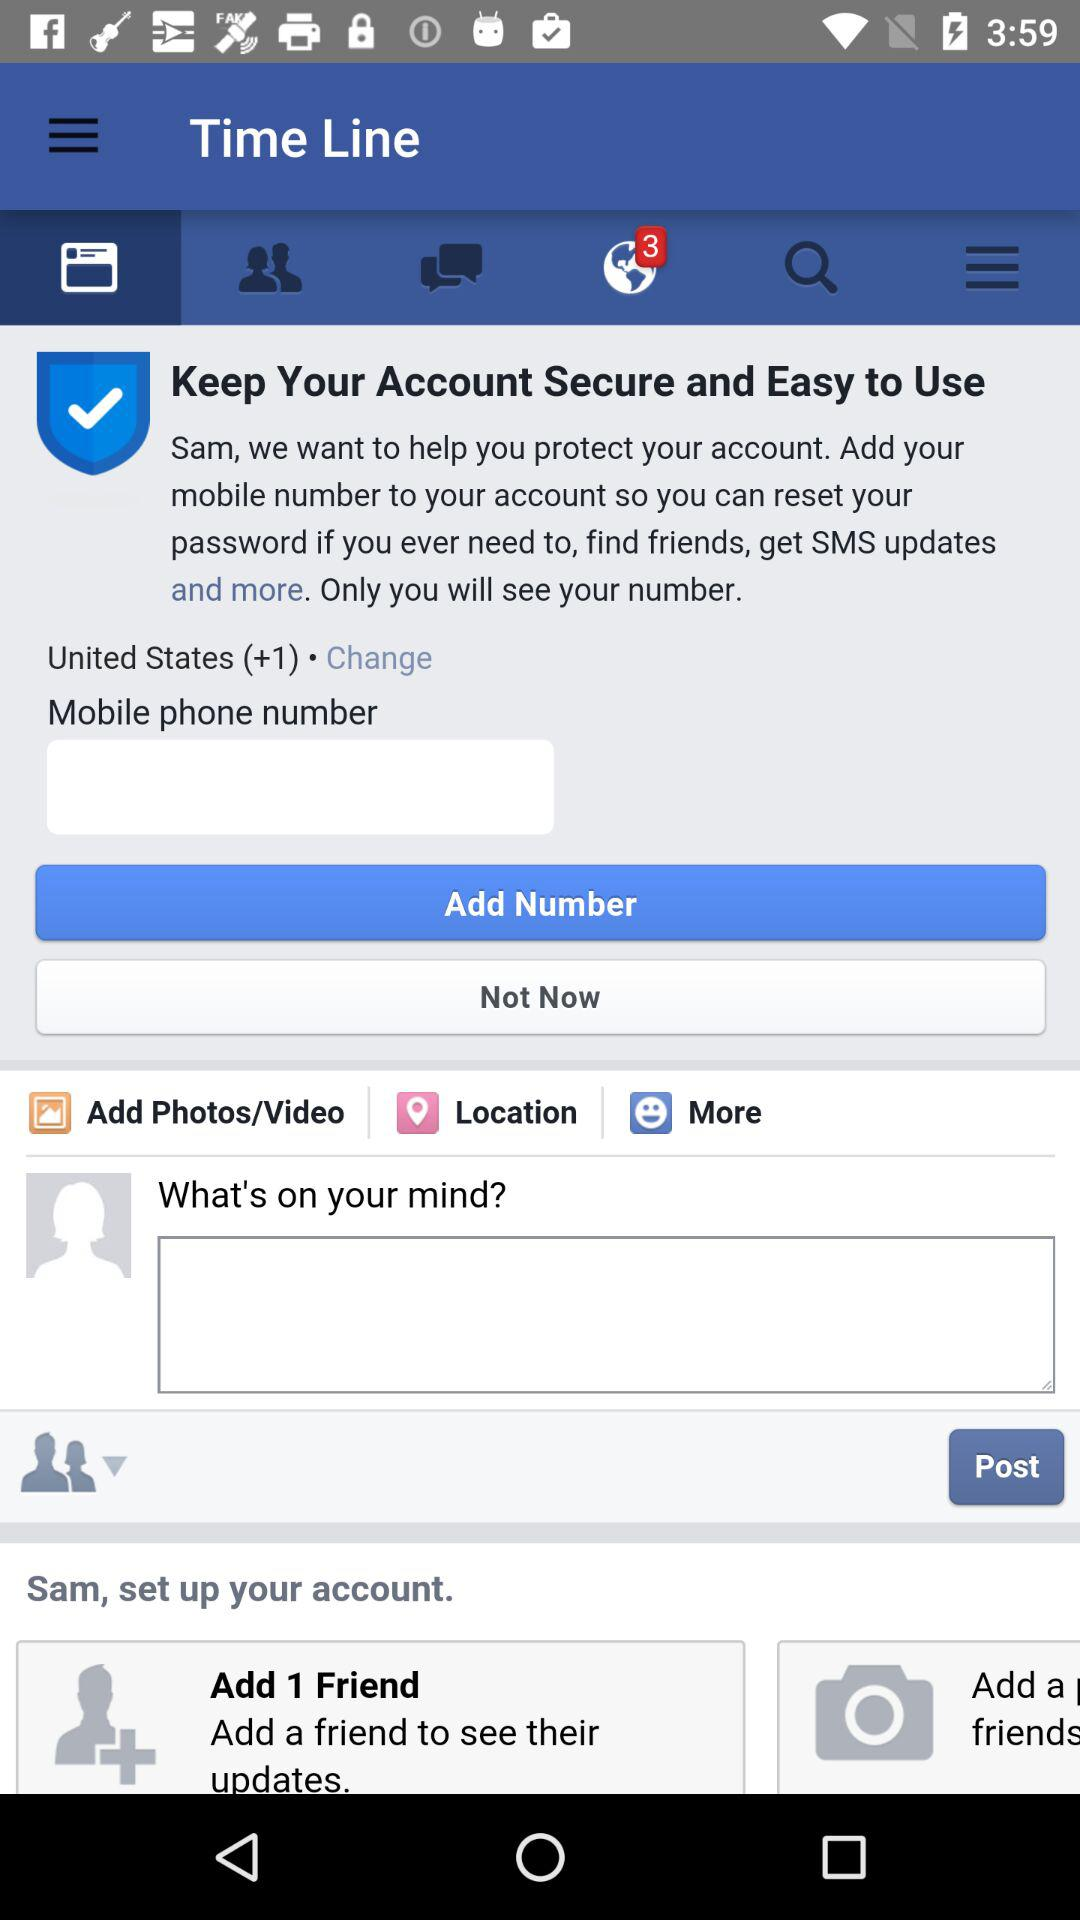What is the country's code? The country's code is +1. 